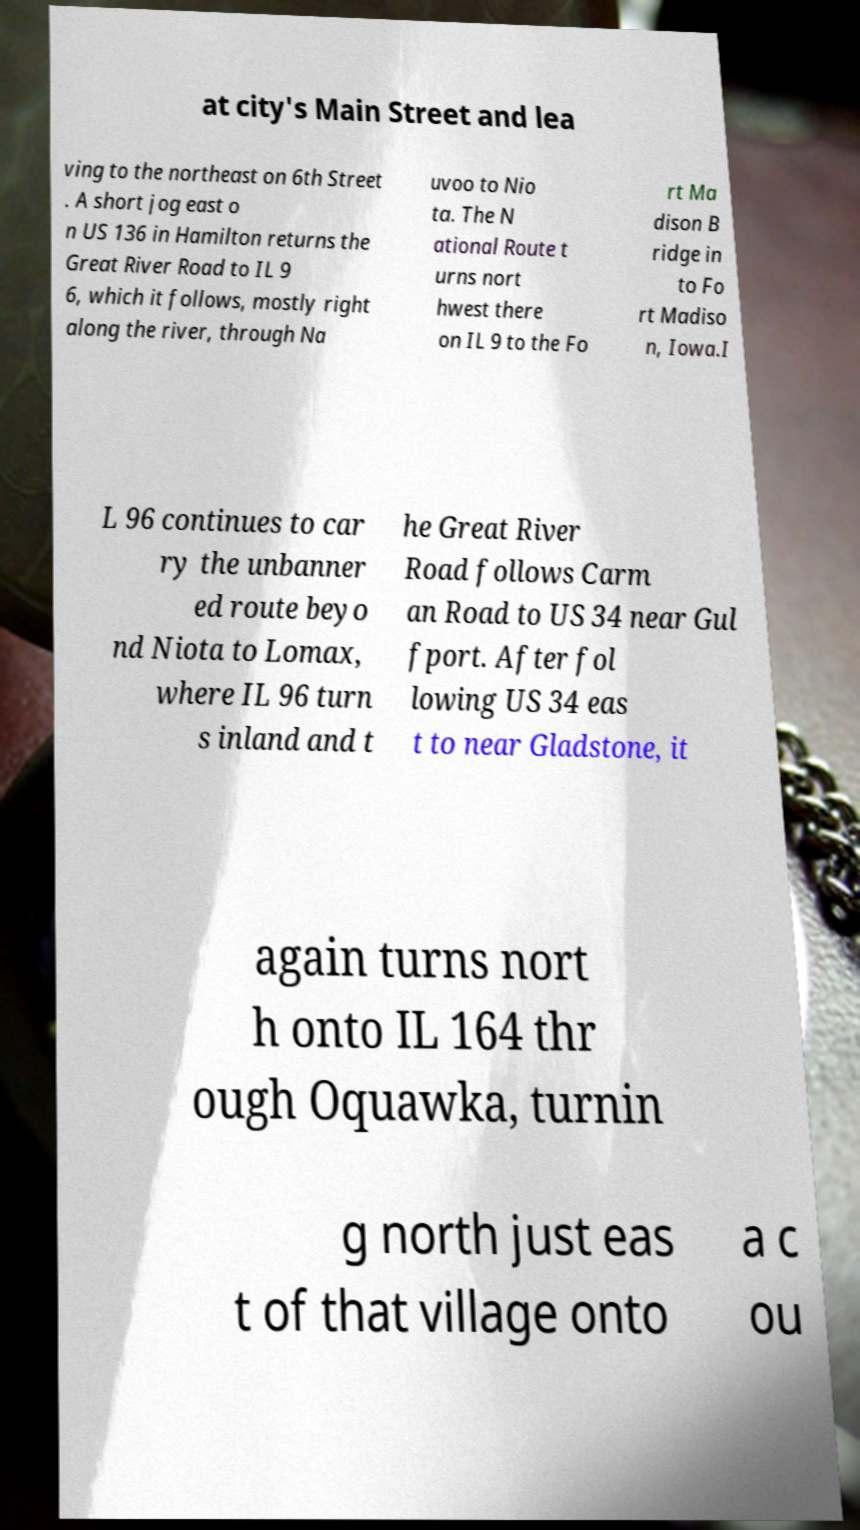Could you assist in decoding the text presented in this image and type it out clearly? at city's Main Street and lea ving to the northeast on 6th Street . A short jog east o n US 136 in Hamilton returns the Great River Road to IL 9 6, which it follows, mostly right along the river, through Na uvoo to Nio ta. The N ational Route t urns nort hwest there on IL 9 to the Fo rt Ma dison B ridge in to Fo rt Madiso n, Iowa.I L 96 continues to car ry the unbanner ed route beyo nd Niota to Lomax, where IL 96 turn s inland and t he Great River Road follows Carm an Road to US 34 near Gul fport. After fol lowing US 34 eas t to near Gladstone, it again turns nort h onto IL 164 thr ough Oquawka, turnin g north just eas t of that village onto a c ou 